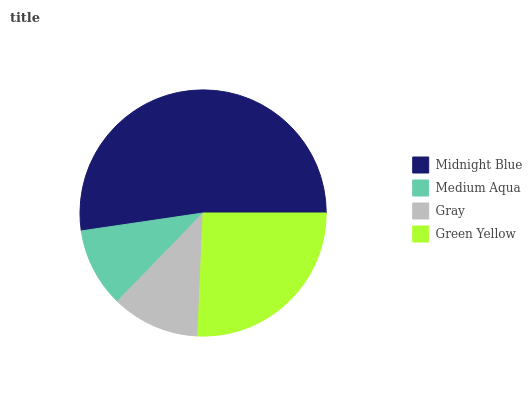Is Medium Aqua the minimum?
Answer yes or no. Yes. Is Midnight Blue the maximum?
Answer yes or no. Yes. Is Gray the minimum?
Answer yes or no. No. Is Gray the maximum?
Answer yes or no. No. Is Gray greater than Medium Aqua?
Answer yes or no. Yes. Is Medium Aqua less than Gray?
Answer yes or no. Yes. Is Medium Aqua greater than Gray?
Answer yes or no. No. Is Gray less than Medium Aqua?
Answer yes or no. No. Is Green Yellow the high median?
Answer yes or no. Yes. Is Gray the low median?
Answer yes or no. Yes. Is Midnight Blue the high median?
Answer yes or no. No. Is Midnight Blue the low median?
Answer yes or no. No. 